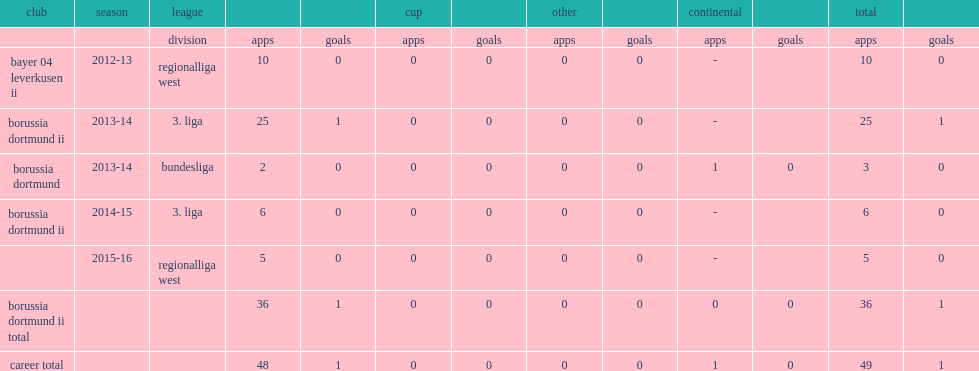In which league of the 2013-14 season was sarr inducted into the borussia dortmund squad? Bundesliga. 